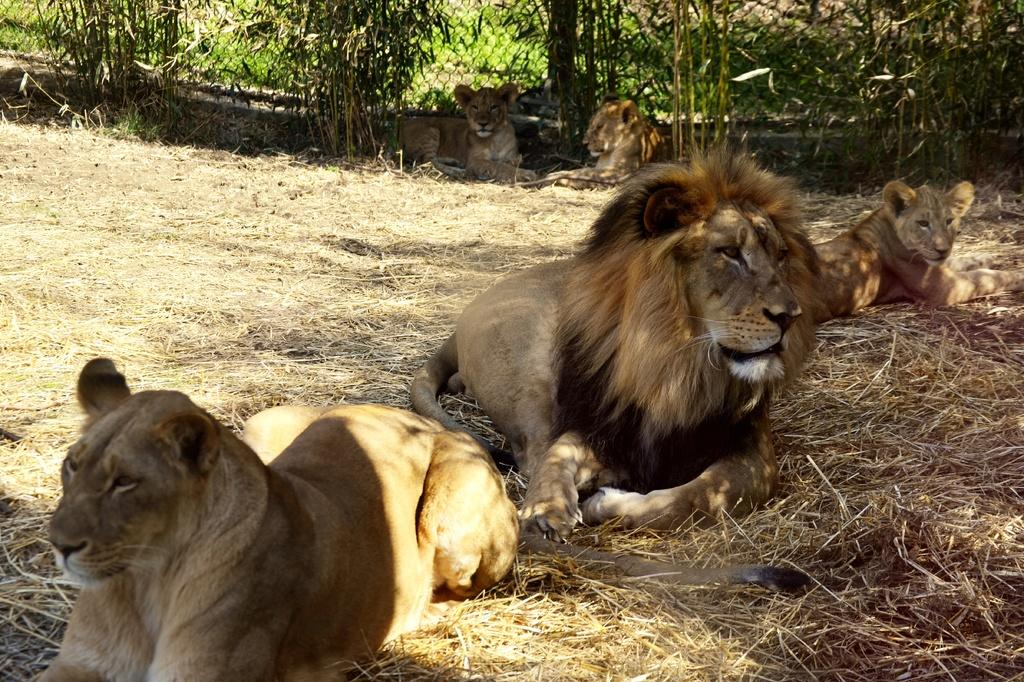What animals are in the center of the image? There are lions in the center of the image. What can be seen in the background of the image? There is a fence, trees, and grass in the background of the image. What type of apparatus is being used by the lions in the image? There is no apparatus present in the image; the lions are simply standing in the center. 